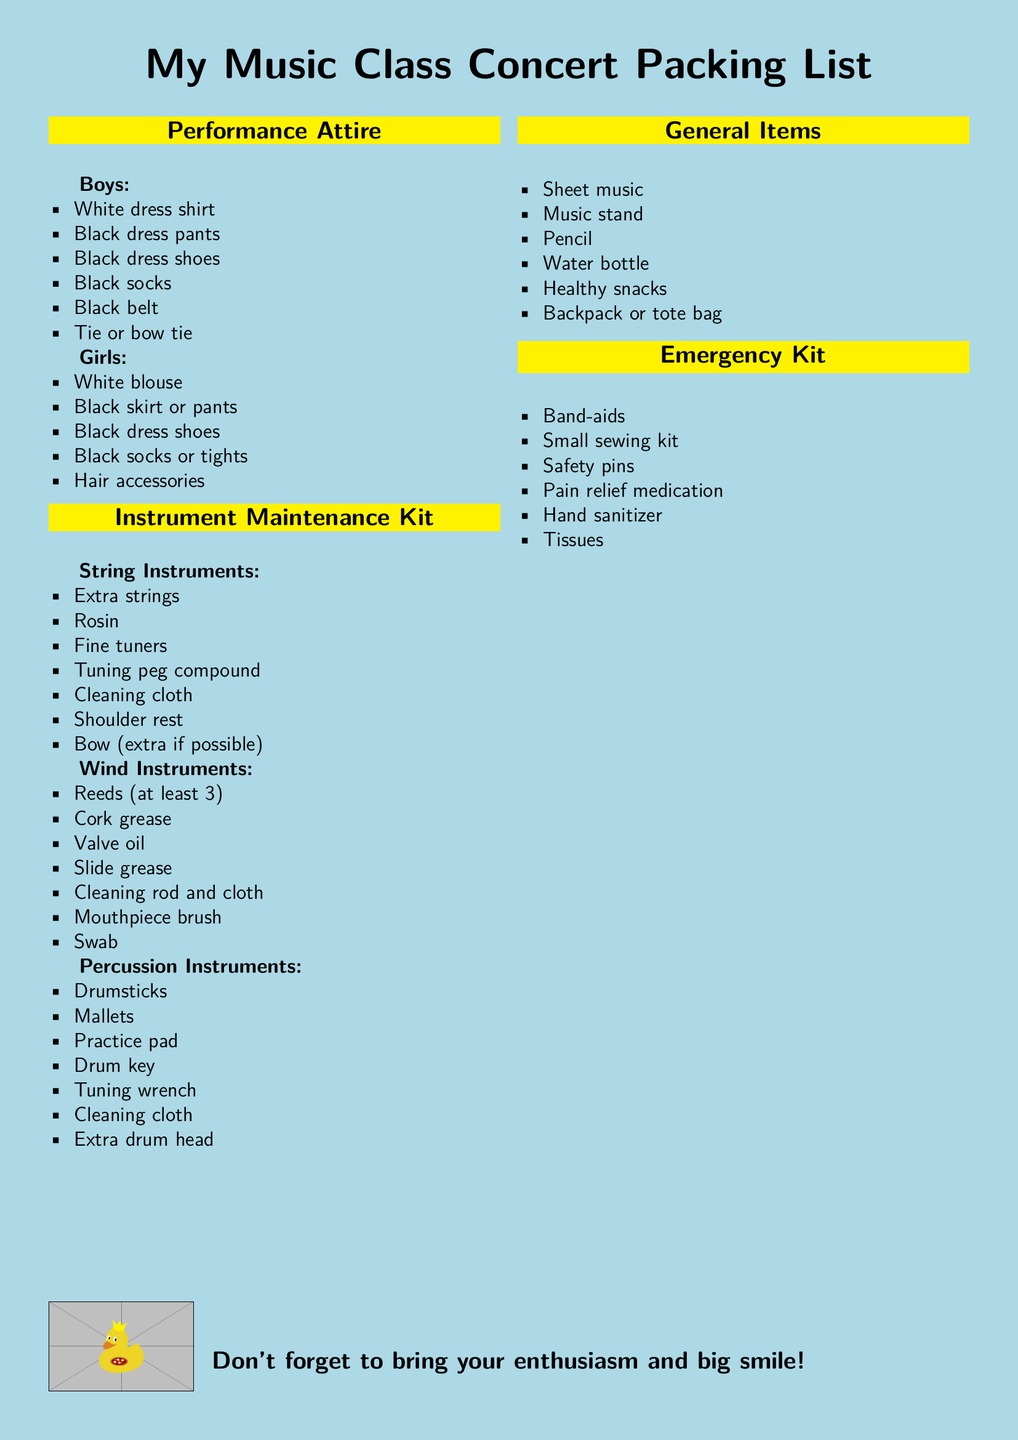What do boys need to wear? The document lists the specific clothing items that boys must wear for the performance, including a white dress shirt, black dress pants, and black dress shoes.
Answer: White dress shirt, black dress pants, black dress shoes, black socks, black belt, tie or bow tie What items are included in the Instrument Maintenance Kit for wind instruments? The document specifies several items necessary for the maintenance of wind instruments, such as reeds and cork grease.
Answer: Reeds, cork grease, valve oil, slide grease, cleaning rod and cloth, mouthpiece brush, swab How many reeds should be brought? The document explicitly states the quantity of reeds needed for wind instruments.
Answer: At least 3 What color pants should girls wear? It is stated in the document that girls should wear either a black skirt or pants for the performance.
Answer: Black What general items are required? The document provides a list of general items that need to be packed, including sheet music and a water bottle.
Answer: Sheet music, music stand, pencil, water bottle, healthy snacks, backpack or tote bag What accessories do girls need for their performance attire? The document mentions a specific item that can be worn as part of the performance attire for girls.
Answer: Hair accessories What is recommended to bring for emergencies? The document lists essential items that should be included in an emergency kit for the concert day.
Answer: Band-aids, small sewing kit, safety pins, pain relief medication, hand sanitizer, tissues 